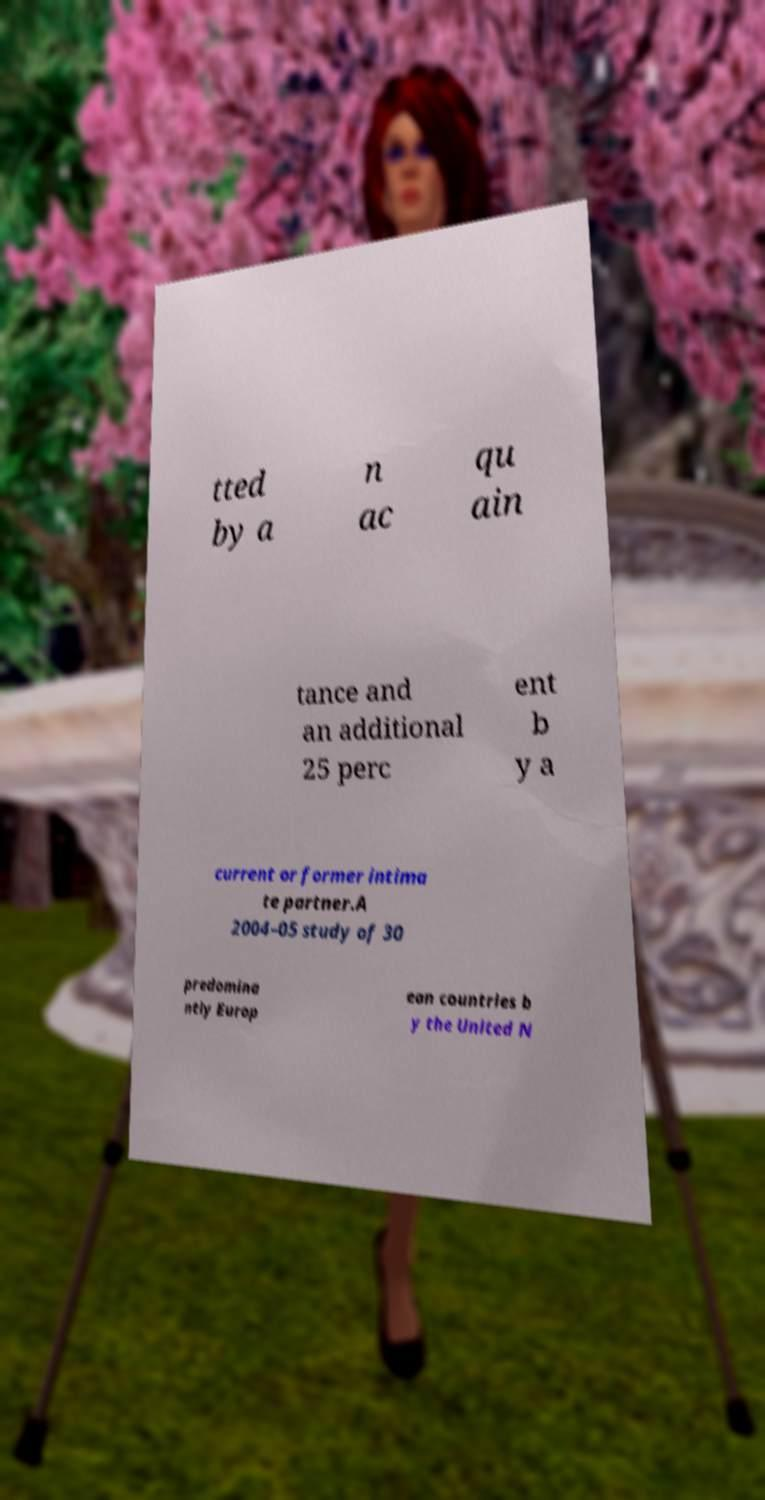There's text embedded in this image that I need extracted. Can you transcribe it verbatim? tted by a n ac qu ain tance and an additional 25 perc ent b y a current or former intima te partner.A 2004–05 study of 30 predomina ntly Europ ean countries b y the United N 